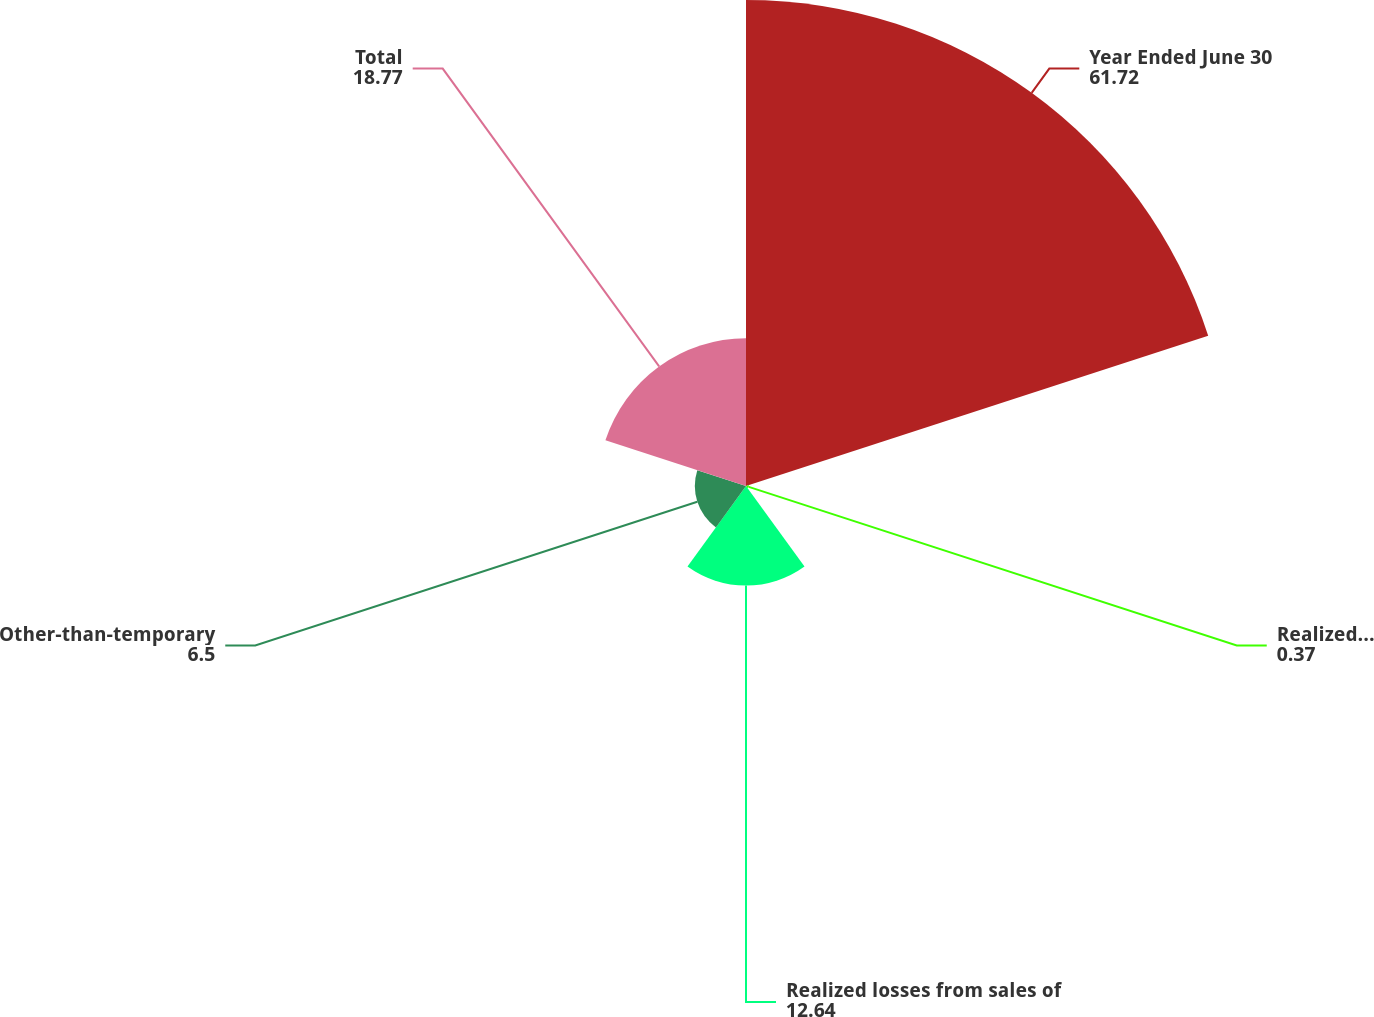Convert chart. <chart><loc_0><loc_0><loc_500><loc_500><pie_chart><fcel>Year Ended June 30<fcel>Realized gains from sales of<fcel>Realized losses from sales of<fcel>Other-than-temporary<fcel>Total<nl><fcel>61.72%<fcel>0.37%<fcel>12.64%<fcel>6.5%<fcel>18.77%<nl></chart> 